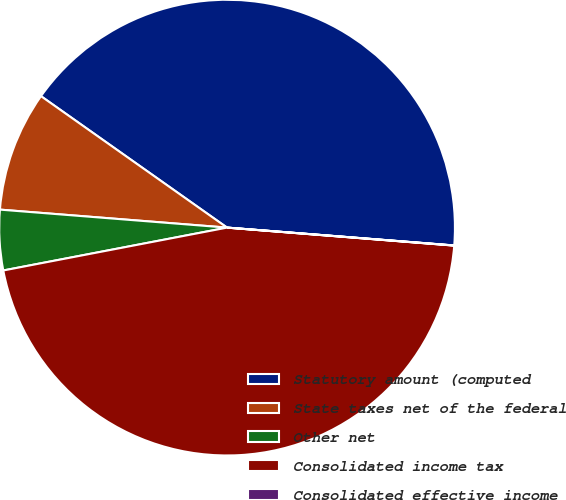<chart> <loc_0><loc_0><loc_500><loc_500><pie_chart><fcel>Statutory amount (computed<fcel>State taxes net of the federal<fcel>Other net<fcel>Consolidated income tax<fcel>Consolidated effective income<nl><fcel>41.46%<fcel>8.53%<fcel>4.27%<fcel>45.73%<fcel>0.01%<nl></chart> 